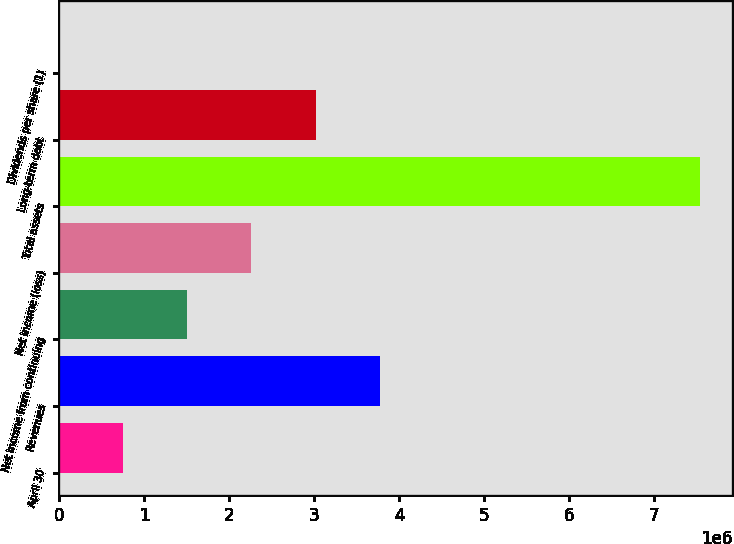Convert chart. <chart><loc_0><loc_0><loc_500><loc_500><bar_chart><fcel>April 30<fcel>Revenues<fcel>Net income from continuing<fcel>Net income (loss)<fcel>Total assets<fcel>Long-term debt<fcel>Dividends per share (1)<nl><fcel>754405<fcel>3.77203e+06<fcel>1.50881e+06<fcel>2.26322e+06<fcel>7.54405e+06<fcel>3.01762e+06<fcel>0.53<nl></chart> 